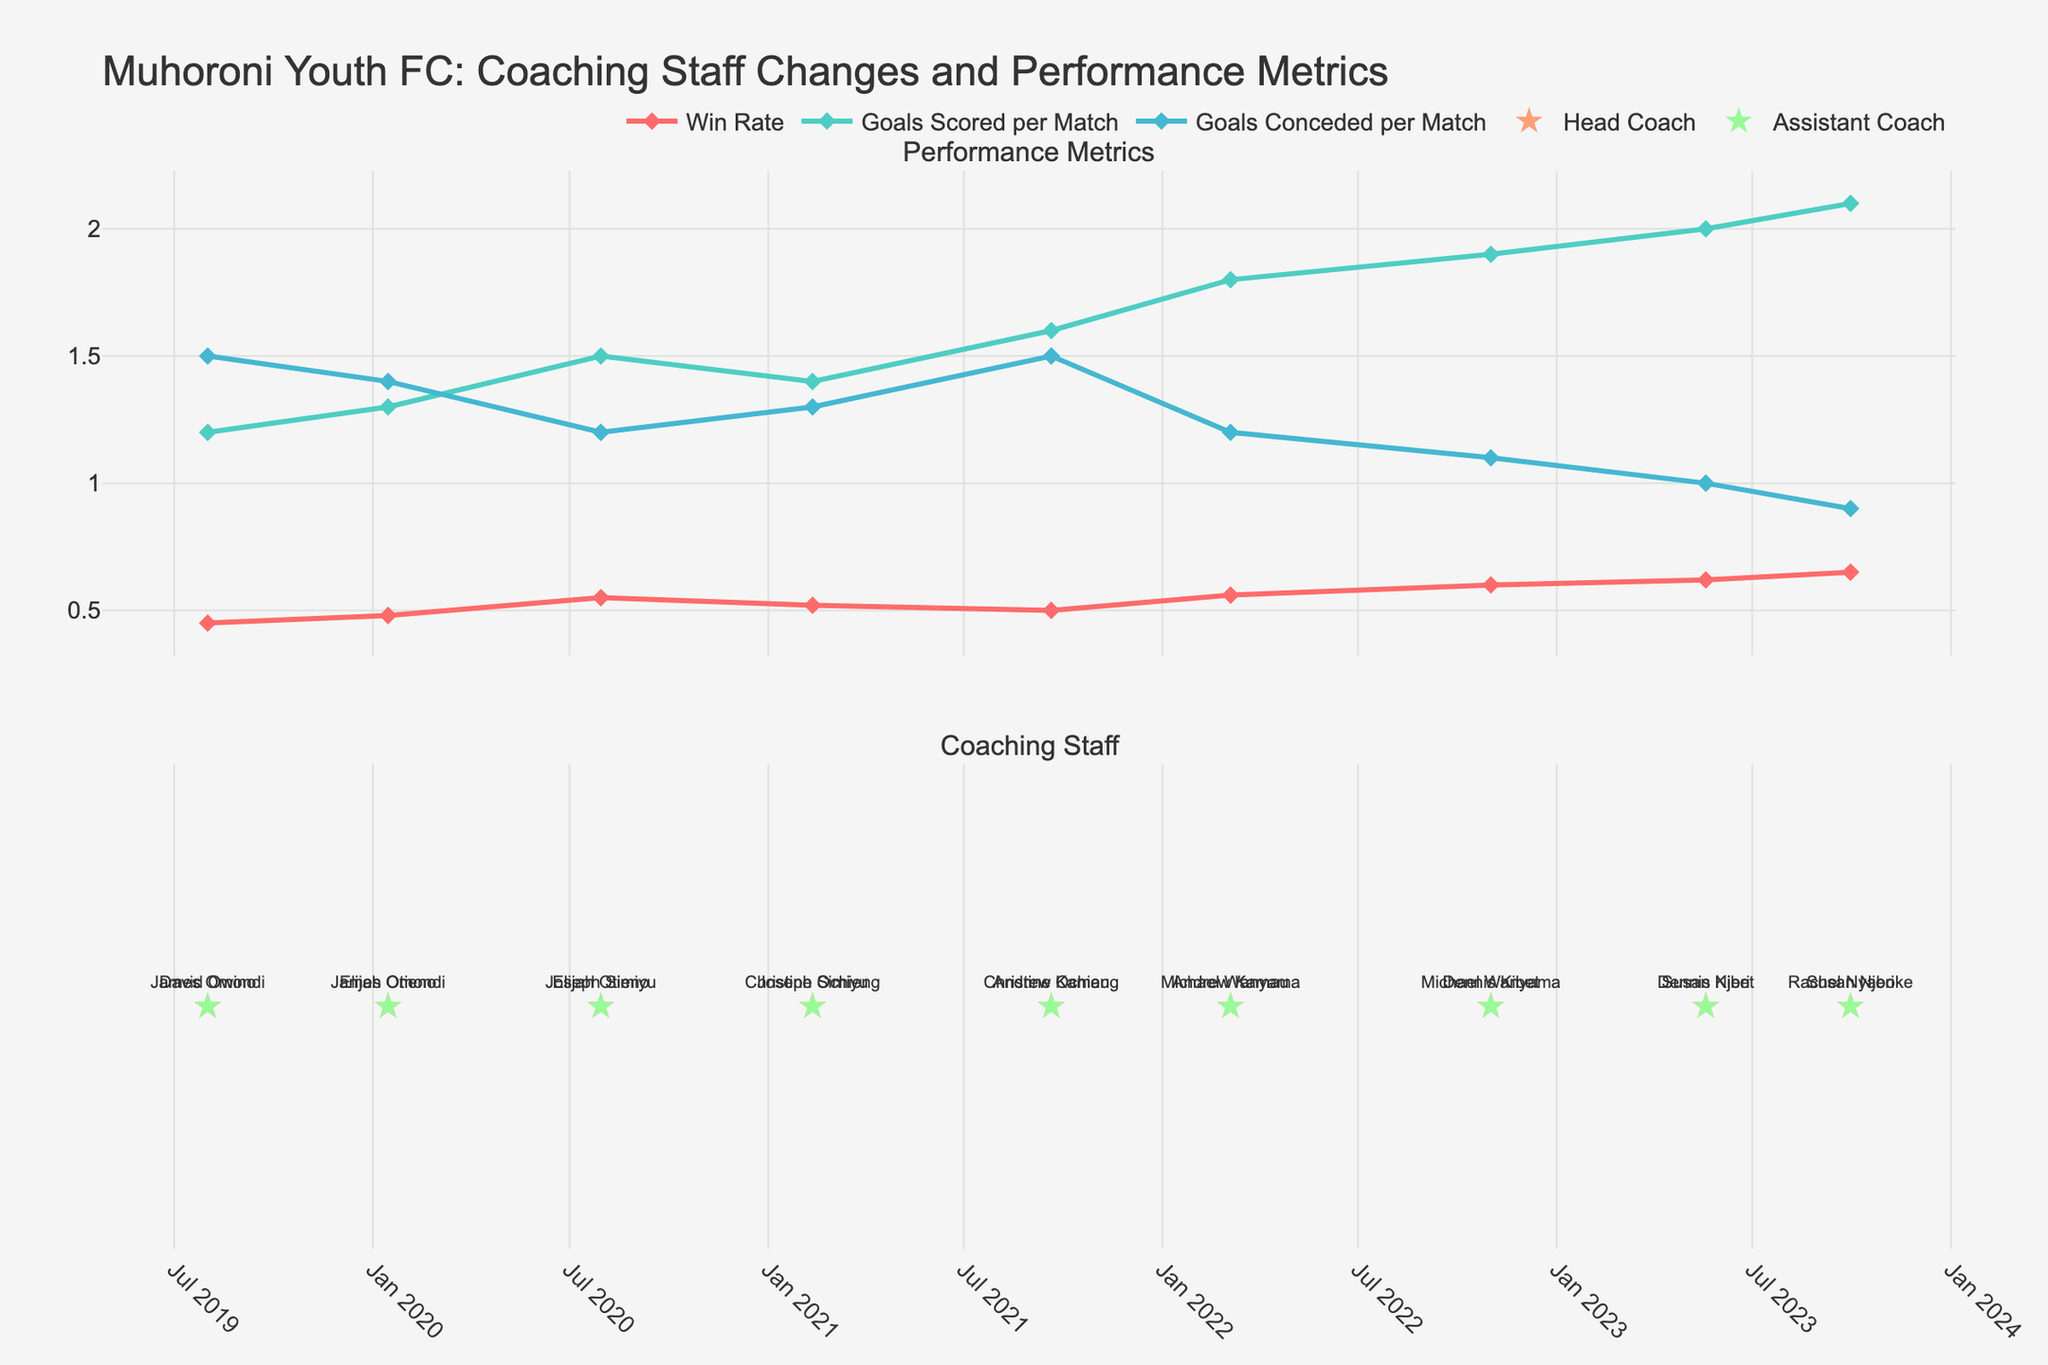What's the title of the figure? The title is located at the top of the figure. It reads "Muhoroni Youth FC: Coaching Staff Changes and Performance Metrics".
Answer: Muhoroni Youth FC: Coaching Staff Changes and Performance Metrics How many changes in the head coach are displayed in the figure? By looking at the “Head Coach” text markers on the second subplot, we can count the number of unique changes in head coaches. There are 5 head coaches shown.
Answer: 5 Which performance metric has the highest value in the entire dataset? By examining the peaks of all three performance metrics, we observe that "Goals Scored per Match" reaches the highest value of 2.1.
Answer: Goals Scored per Match Did the "Win Rate" improve or decline after Andrew Kamau became the head coach compared to his predecessor? Andrew Kamau became head coach on 2021-09-20, and we need to compare the win rate before and after this date. "Win Rate" was 0.52 before and became 0.50 after Andrew Kamau's appointment. It shows a decline in win rate.
Answer: Decline What's the average "Goals Conceded per Match" under Dennis Kibet's coaching periods? Dennis Kibet’s tenure first starts from 2022-11-01 to his following change on 2023-09-30. During this time, the data points are 1.1 and 1.0. To calculate the average, we sum these values (1.1 + 1.0 = 2.1) and divide by 2.
Answer: 1.05 Which coach had the most positive impact on both "Win Rate" and "Goals Scored per Match"? We need to observe the changes in the "Win Rate" and "Goals Scored per Match" during each coach’s tenure. Dennis Kibet’s tenure shows the highest values in both metrics reaching 0.62 in "Win Rate" and 2.0 - 2.1 in "Goals Scored per Match".
Answer: Dennis Kibet During which performance metric focus did "Win Rate" exceed 0.55 for the first time? The "Win Rate" line first exceeds 0.55 during "Consistent Training Drills" starting from 2022-03-05.
Answer: Consistent Training Drills What is the trend of "Goals Conceded per Match" from the beginning to the end of the dataset? We need to track the data points of "Goals Conceded per Match" from the start to the end of the timeline. The value decreases from 1.5 in 2019 to 0.9 in 2023, indicating an overall decreasing trend.
Answer: Decreasing Who was the assistant coach when the "Goals Scored per Match" reached its highest value, and what was that value? The peak of "Goals Scored per Match" is 2.1 on 2023-09-30, and at this point, the assistant coach was Susan Njeri.
Answer: Susan Njeri, 2.1 